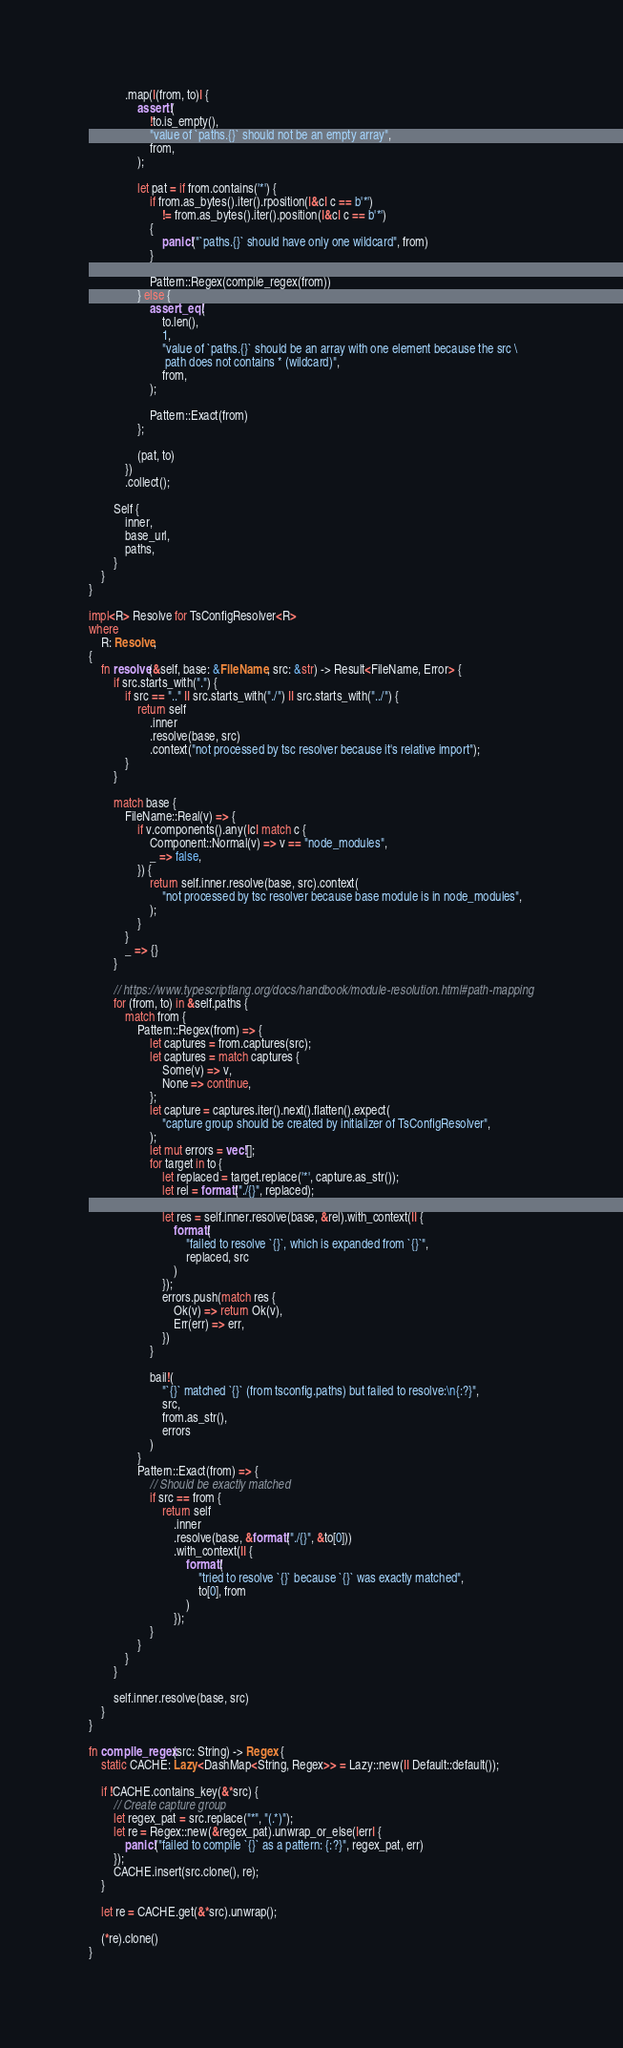Convert code to text. <code><loc_0><loc_0><loc_500><loc_500><_Rust_>            .map(|(from, to)| {
                assert!(
                    !to.is_empty(),
                    "value of `paths.{}` should not be an empty array",
                    from,
                );

                let pat = if from.contains('*') {
                    if from.as_bytes().iter().rposition(|&c| c == b'*')
                        != from.as_bytes().iter().position(|&c| c == b'*')
                    {
                        panic!("`paths.{}` should have only one wildcard", from)
                    }

                    Pattern::Regex(compile_regex(from))
                } else {
                    assert_eq!(
                        to.len(),
                        1,
                        "value of `paths.{}` should be an array with one element because the src \
                         path does not contains * (wildcard)",
                        from,
                    );

                    Pattern::Exact(from)
                };

                (pat, to)
            })
            .collect();

        Self {
            inner,
            base_url,
            paths,
        }
    }
}

impl<R> Resolve for TsConfigResolver<R>
where
    R: Resolve,
{
    fn resolve(&self, base: &FileName, src: &str) -> Result<FileName, Error> {
        if src.starts_with(".") {
            if src == ".." || src.starts_with("./") || src.starts_with("../") {
                return self
                    .inner
                    .resolve(base, src)
                    .context("not processed by tsc resolver because it's relative import");
            }
        }

        match base {
            FileName::Real(v) => {
                if v.components().any(|c| match c {
                    Component::Normal(v) => v == "node_modules",
                    _ => false,
                }) {
                    return self.inner.resolve(base, src).context(
                        "not processed by tsc resolver because base module is in node_modules",
                    );
                }
            }
            _ => {}
        }

        // https://www.typescriptlang.org/docs/handbook/module-resolution.html#path-mapping
        for (from, to) in &self.paths {
            match from {
                Pattern::Regex(from) => {
                    let captures = from.captures(src);
                    let captures = match captures {
                        Some(v) => v,
                        None => continue,
                    };
                    let capture = captures.iter().next().flatten().expect(
                        "capture group should be created by initializer of TsConfigResolver",
                    );
                    let mut errors = vec![];
                    for target in to {
                        let replaced = target.replace('*', capture.as_str());
                        let rel = format!("./{}", replaced);

                        let res = self.inner.resolve(base, &rel).with_context(|| {
                            format!(
                                "failed to resolve `{}`, which is expanded from `{}`",
                                replaced, src
                            )
                        });
                        errors.push(match res {
                            Ok(v) => return Ok(v),
                            Err(err) => err,
                        })
                    }

                    bail!(
                        "`{}` matched `{}` (from tsconfig.paths) but failed to resolve:\n{:?}",
                        src,
                        from.as_str(),
                        errors
                    )
                }
                Pattern::Exact(from) => {
                    // Should be exactly matched
                    if src == from {
                        return self
                            .inner
                            .resolve(base, &format!("./{}", &to[0]))
                            .with_context(|| {
                                format!(
                                    "tried to resolve `{}` because `{}` was exactly matched",
                                    to[0], from
                                )
                            });
                    }
                }
            }
        }

        self.inner.resolve(base, src)
    }
}

fn compile_regex(src: String) -> Regex {
    static CACHE: Lazy<DashMap<String, Regex>> = Lazy::new(|| Default::default());

    if !CACHE.contains_key(&*src) {
        // Create capture group
        let regex_pat = src.replace("*", "(.*)");
        let re = Regex::new(&regex_pat).unwrap_or_else(|err| {
            panic!("failed to compile `{}` as a pattern: {:?}", regex_pat, err)
        });
        CACHE.insert(src.clone(), re);
    }

    let re = CACHE.get(&*src).unwrap();

    (*re).clone()
}
</code> 